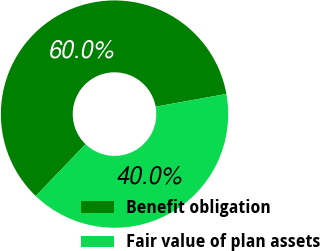Convert chart to OTSL. <chart><loc_0><loc_0><loc_500><loc_500><pie_chart><fcel>Benefit obligation<fcel>Fair value of plan assets<nl><fcel>59.97%<fcel>40.03%<nl></chart> 